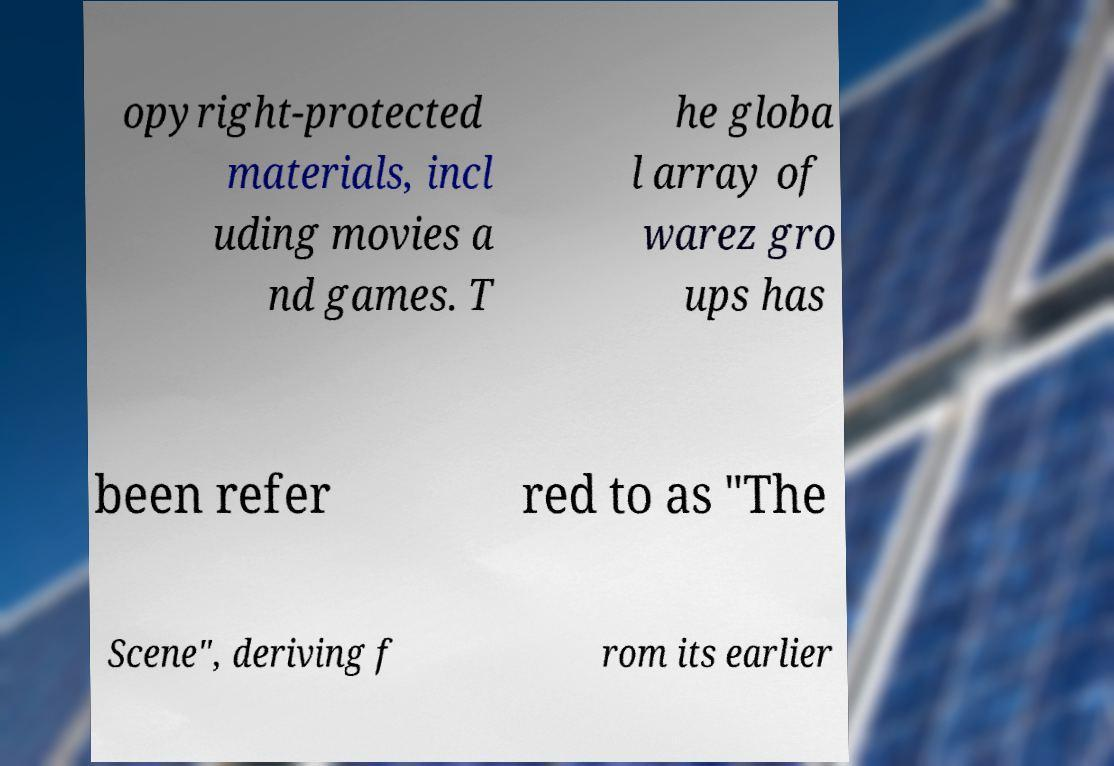Please identify and transcribe the text found in this image. opyright-protected materials, incl uding movies a nd games. T he globa l array of warez gro ups has been refer red to as "The Scene", deriving f rom its earlier 